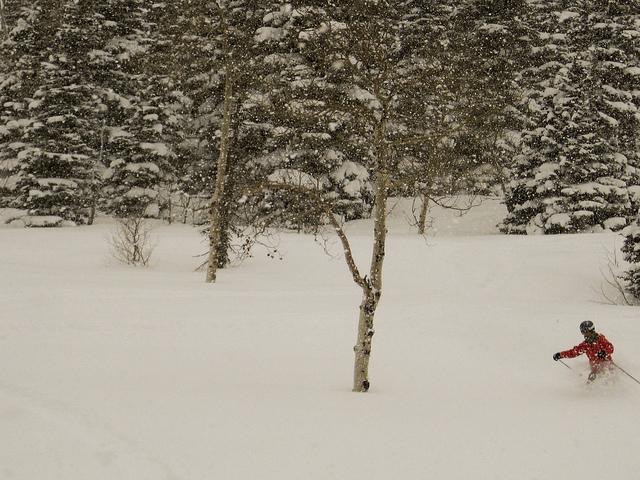Is the ground full of snow?
Answer briefly. Yes. What color jacket is the skier wearing?
Answer briefly. Red. What activity is being done?
Write a very short answer. Skiing. 